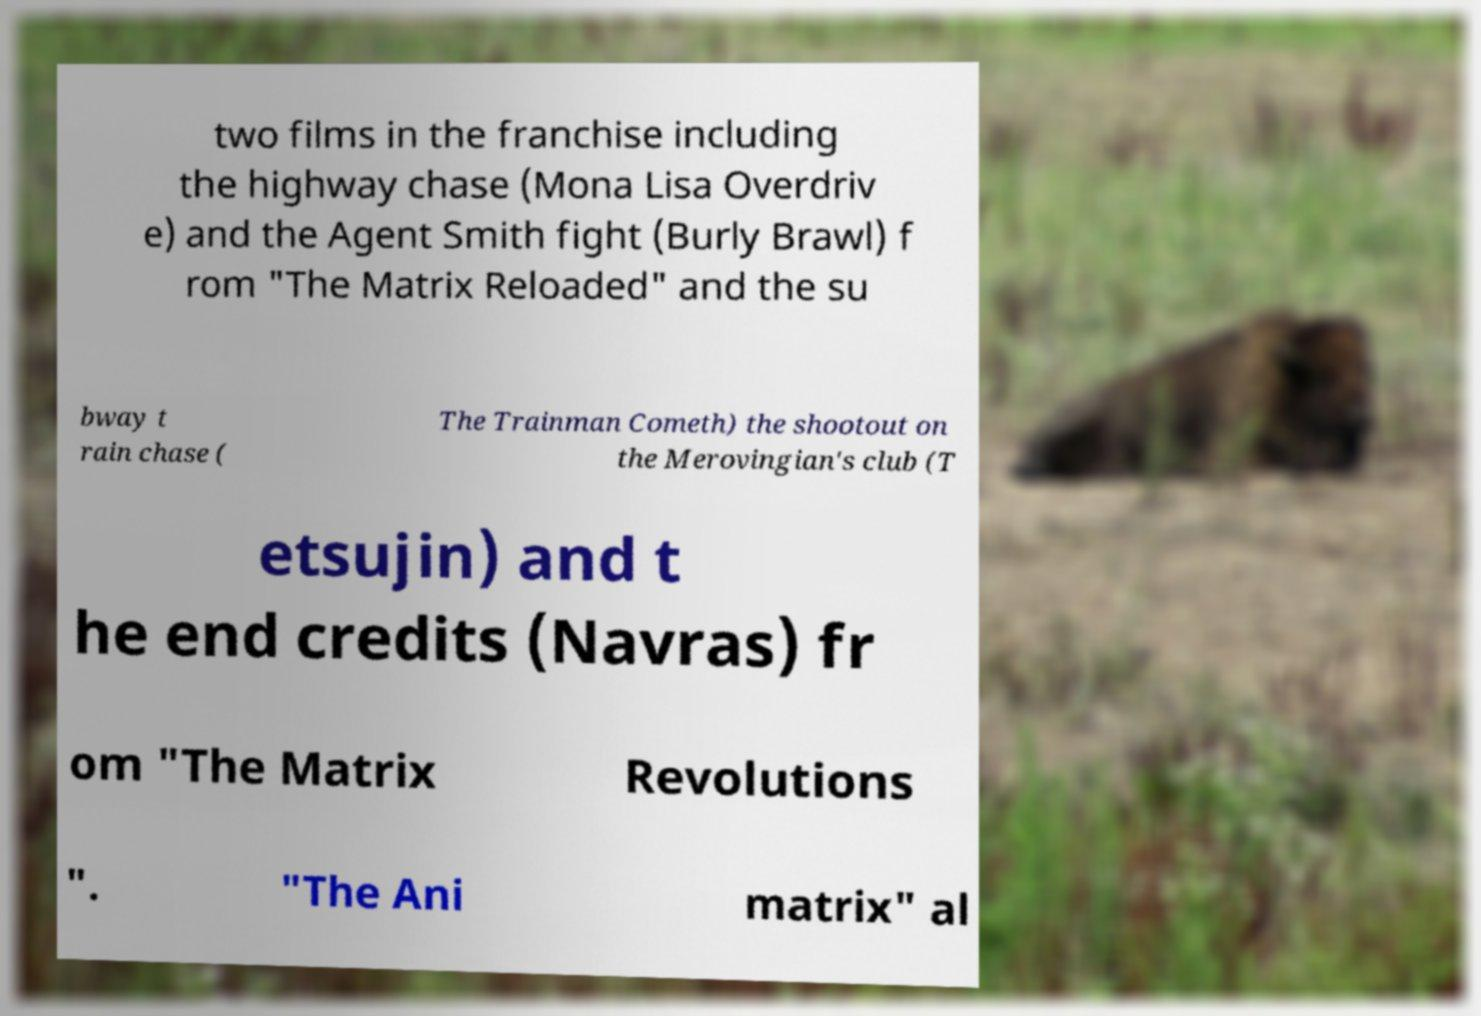Please read and relay the text visible in this image. What does it say? two films in the franchise including the highway chase (Mona Lisa Overdriv e) and the Agent Smith fight (Burly Brawl) f rom "The Matrix Reloaded" and the su bway t rain chase ( The Trainman Cometh) the shootout on the Merovingian's club (T etsujin) and t he end credits (Navras) fr om "The Matrix Revolutions ". "The Ani matrix" al 